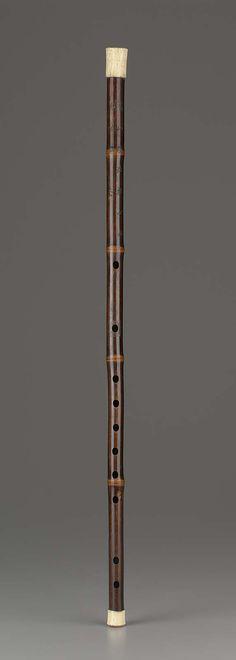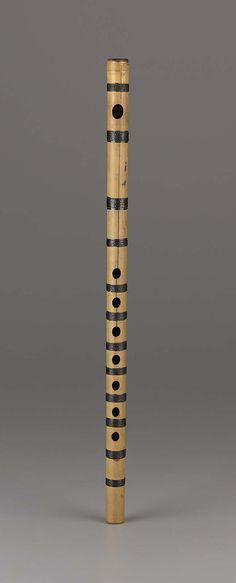The first image is the image on the left, the second image is the image on the right. Examine the images to the left and right. Is the description "The instrument on the left has several rings going around its body." accurate? Answer yes or no. Yes. The first image is the image on the left, the second image is the image on the right. Examine the images to the left and right. Is the description "There is a single  brown wooden flute standing up with one hole for the month and seven hole at the bottom for the fingers to cover." accurate? Answer yes or no. Yes. 